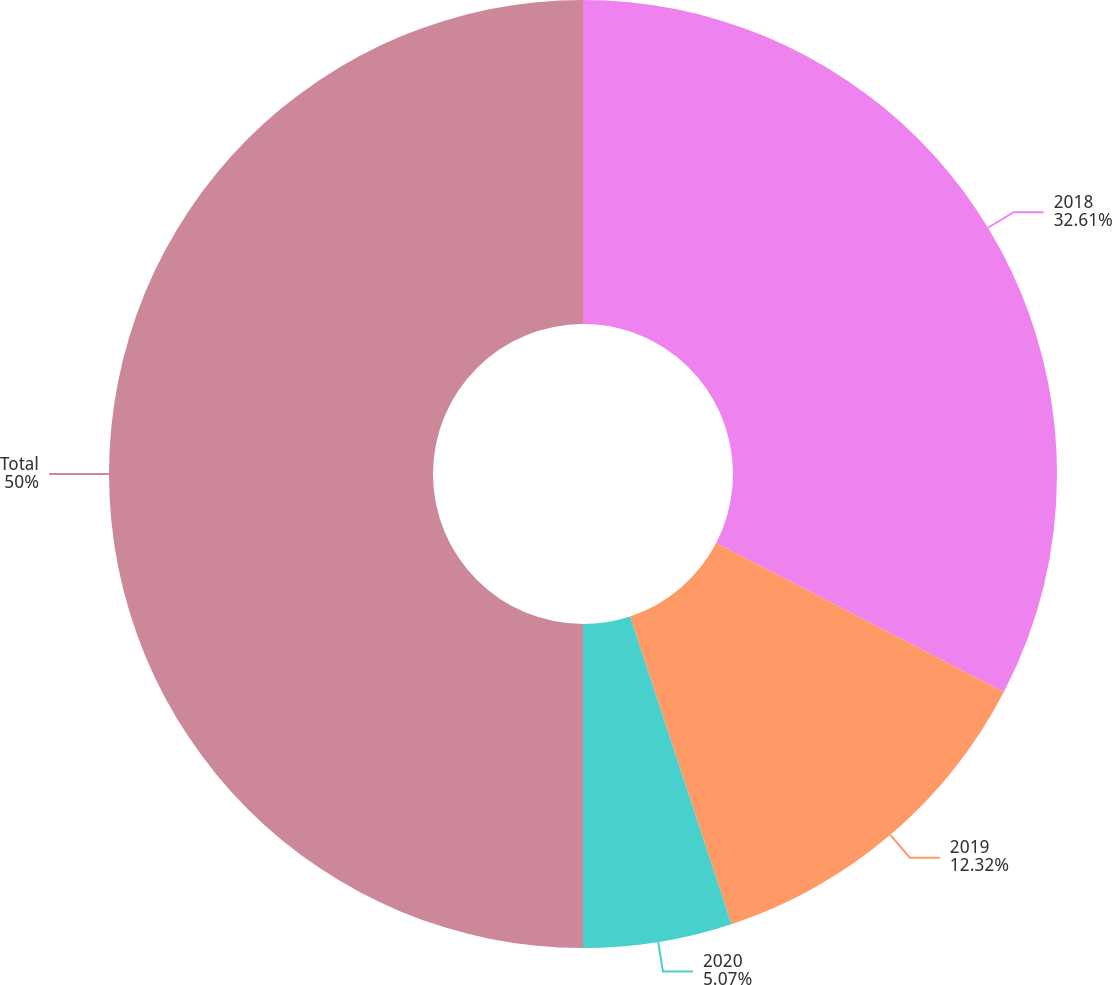Convert chart to OTSL. <chart><loc_0><loc_0><loc_500><loc_500><pie_chart><fcel>2018<fcel>2019<fcel>2020<fcel>Total<nl><fcel>32.61%<fcel>12.32%<fcel>5.07%<fcel>50.0%<nl></chart> 